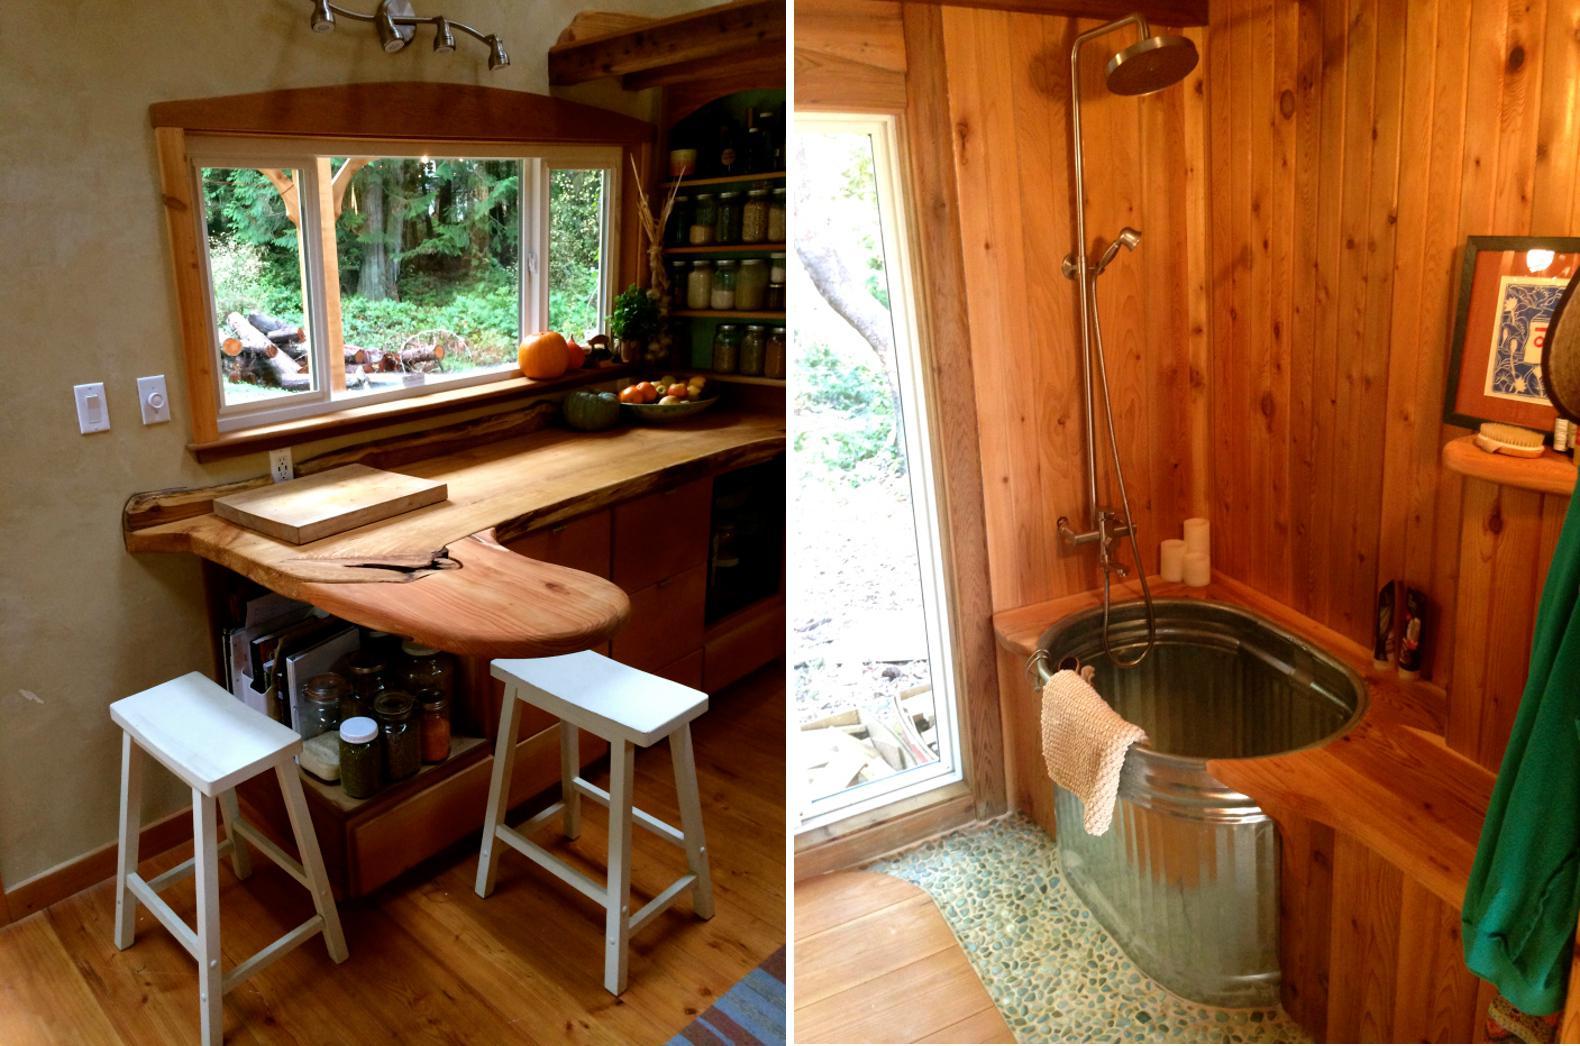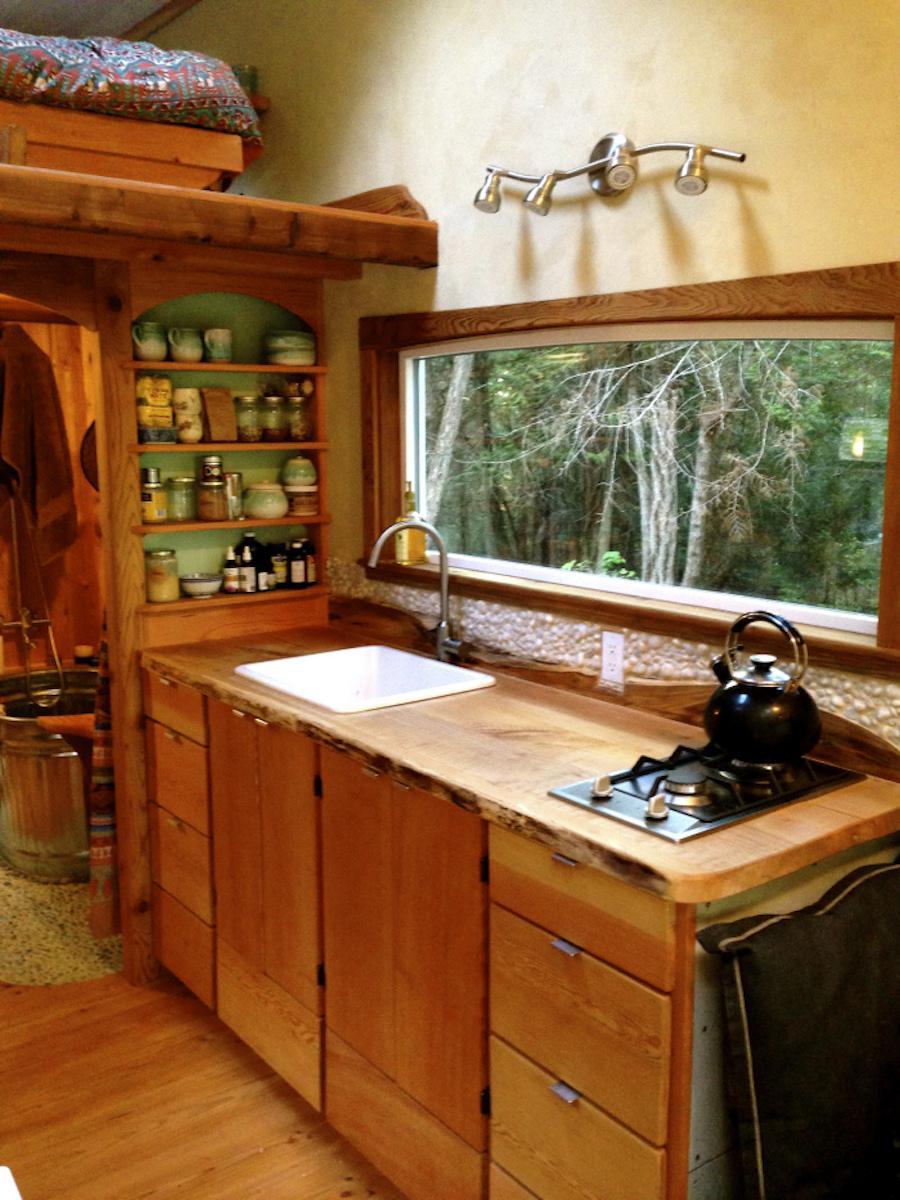The first image is the image on the left, the second image is the image on the right. Assess this claim about the two images: "An image of a yurt's interior shows a wood slab countertop that ends with a curving corner.". Correct or not? Answer yes or no. Yes. The first image is the image on the left, the second image is the image on the right. For the images shown, is this caption "In one image, a white kitchen sink is built into a wooden cabinet, and is situated in front of a window near wall shelves stocked with kitchen supplies." true? Answer yes or no. Yes. 